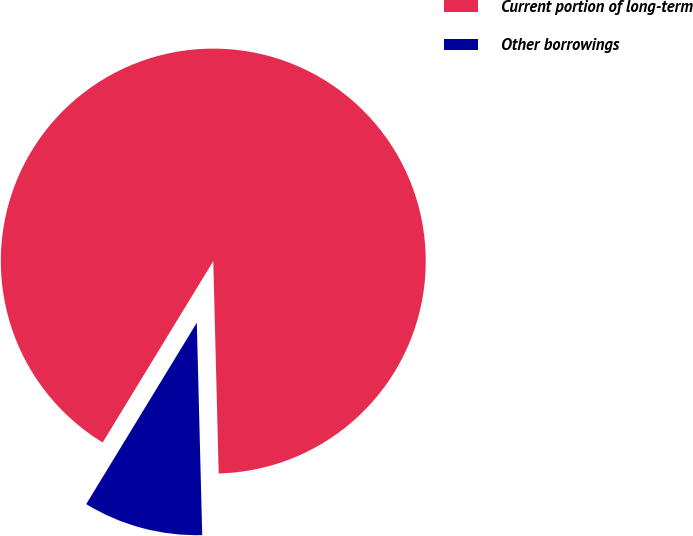Convert chart to OTSL. <chart><loc_0><loc_0><loc_500><loc_500><pie_chart><fcel>Current portion of long-term<fcel>Other borrowings<nl><fcel>90.88%<fcel>9.12%<nl></chart> 